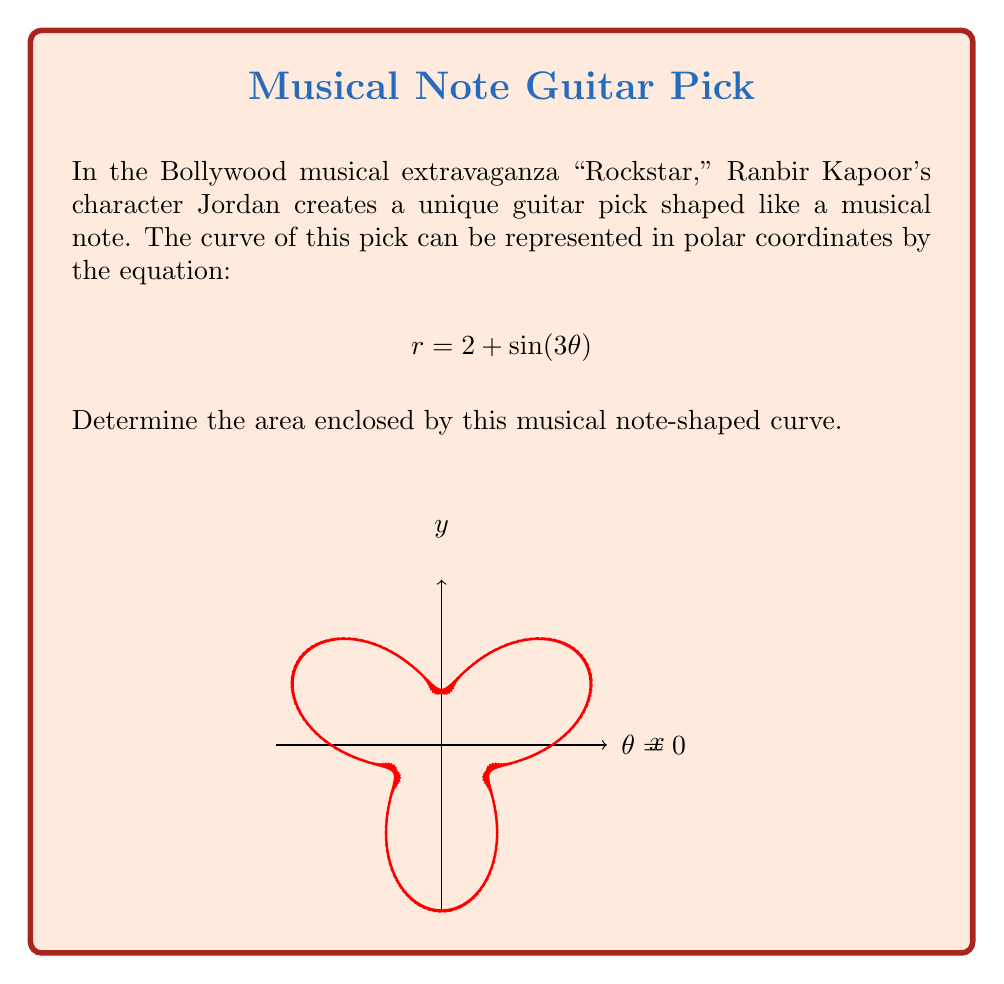Can you answer this question? To find the area enclosed by the curve, we'll use the formula for area in polar coordinates:

$$A = \frac{1}{2} \int_{0}^{2\pi} r^2 d\theta$$

Step 1: Substitute the given equation into the formula:
$$A = \frac{1}{2} \int_{0}^{2\pi} (2 + \sin(3\theta))^2 d\theta$$

Step 2: Expand the squared term:
$$A = \frac{1}{2} \int_{0}^{2\pi} (4 + 4\sin(3\theta) + \sin^2(3\theta)) d\theta$$

Step 3: Integrate each term:

a) $\int_{0}^{2\pi} 4 d\theta = 4\theta \big|_{0}^{2\pi} = 8\pi$

b) $\int_{0}^{2\pi} 4\sin(3\theta) d\theta = -\frac{4}{3}\cos(3\theta) \big|_{0}^{2\pi} = 0$

c) For $\int_{0}^{2\pi} \sin^2(3\theta) d\theta$, use the identity $\sin^2 x = \frac{1 - \cos(2x)}{2}$:

   $\int_{0}^{2\pi} \sin^2(3\theta) d\theta = \int_{0}^{2\pi} \frac{1 - \cos(6\theta)}{2} d\theta$
   
   $= \frac{1}{2}\theta - \frac{1}{12}\sin(6\theta) \big|_{0}^{2\pi} = \pi$

Step 4: Sum up the results:
$$A = \frac{1}{2} (8\pi + 0 + \pi) = \frac{9\pi}{2}$$

Therefore, the area enclosed by the musical note-shaped curve is $\frac{9\pi}{2}$ square units.
Answer: $\frac{9\pi}{2}$ square units 